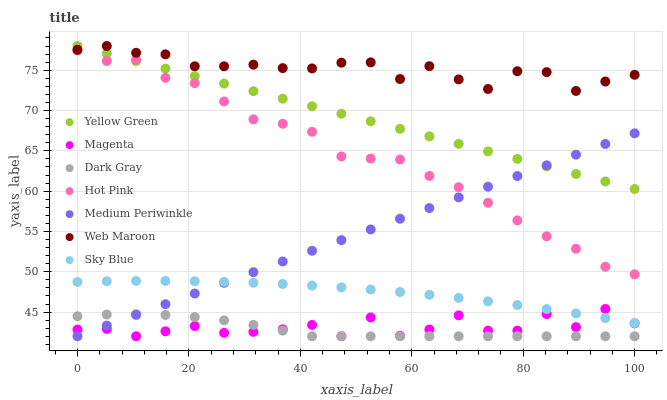Does Dark Gray have the minimum area under the curve?
Answer yes or no. Yes. Does Web Maroon have the maximum area under the curve?
Answer yes or no. Yes. Does Medium Periwinkle have the minimum area under the curve?
Answer yes or no. No. Does Medium Periwinkle have the maximum area under the curve?
Answer yes or no. No. Is Medium Periwinkle the smoothest?
Answer yes or no. Yes. Is Magenta the roughest?
Answer yes or no. Yes. Is Hot Pink the smoothest?
Answer yes or no. No. Is Hot Pink the roughest?
Answer yes or no. No. Does Medium Periwinkle have the lowest value?
Answer yes or no. Yes. Does Hot Pink have the lowest value?
Answer yes or no. No. Does Web Maroon have the highest value?
Answer yes or no. Yes. Does Medium Periwinkle have the highest value?
Answer yes or no. No. Is Dark Gray less than Sky Blue?
Answer yes or no. Yes. Is Sky Blue greater than Dark Gray?
Answer yes or no. Yes. Does Medium Periwinkle intersect Sky Blue?
Answer yes or no. Yes. Is Medium Periwinkle less than Sky Blue?
Answer yes or no. No. Is Medium Periwinkle greater than Sky Blue?
Answer yes or no. No. Does Dark Gray intersect Sky Blue?
Answer yes or no. No. 